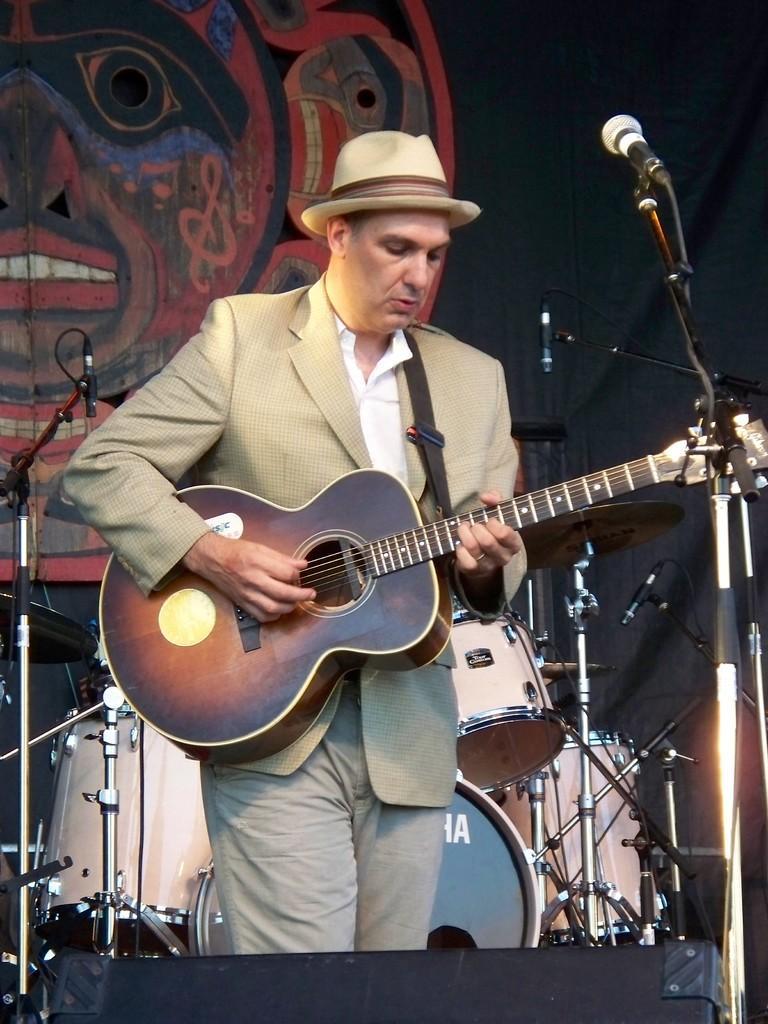In one or two sentences, can you explain what this image depicts? In the middle there is a man he wear suit ,trouser and what ,he is playing guitar. In the background there are drums ,mic stands. 